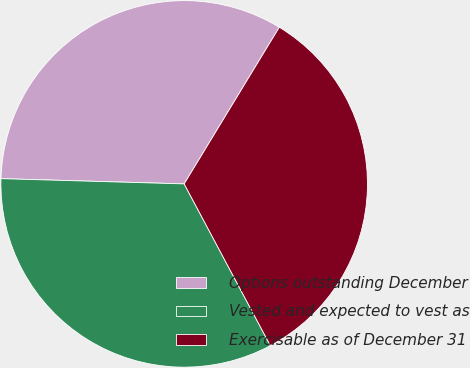Convert chart to OTSL. <chart><loc_0><loc_0><loc_500><loc_500><pie_chart><fcel>Options outstanding December<fcel>Vested and expected to vest as<fcel>Exercisable as of December 31<nl><fcel>33.23%<fcel>33.25%<fcel>33.52%<nl></chart> 